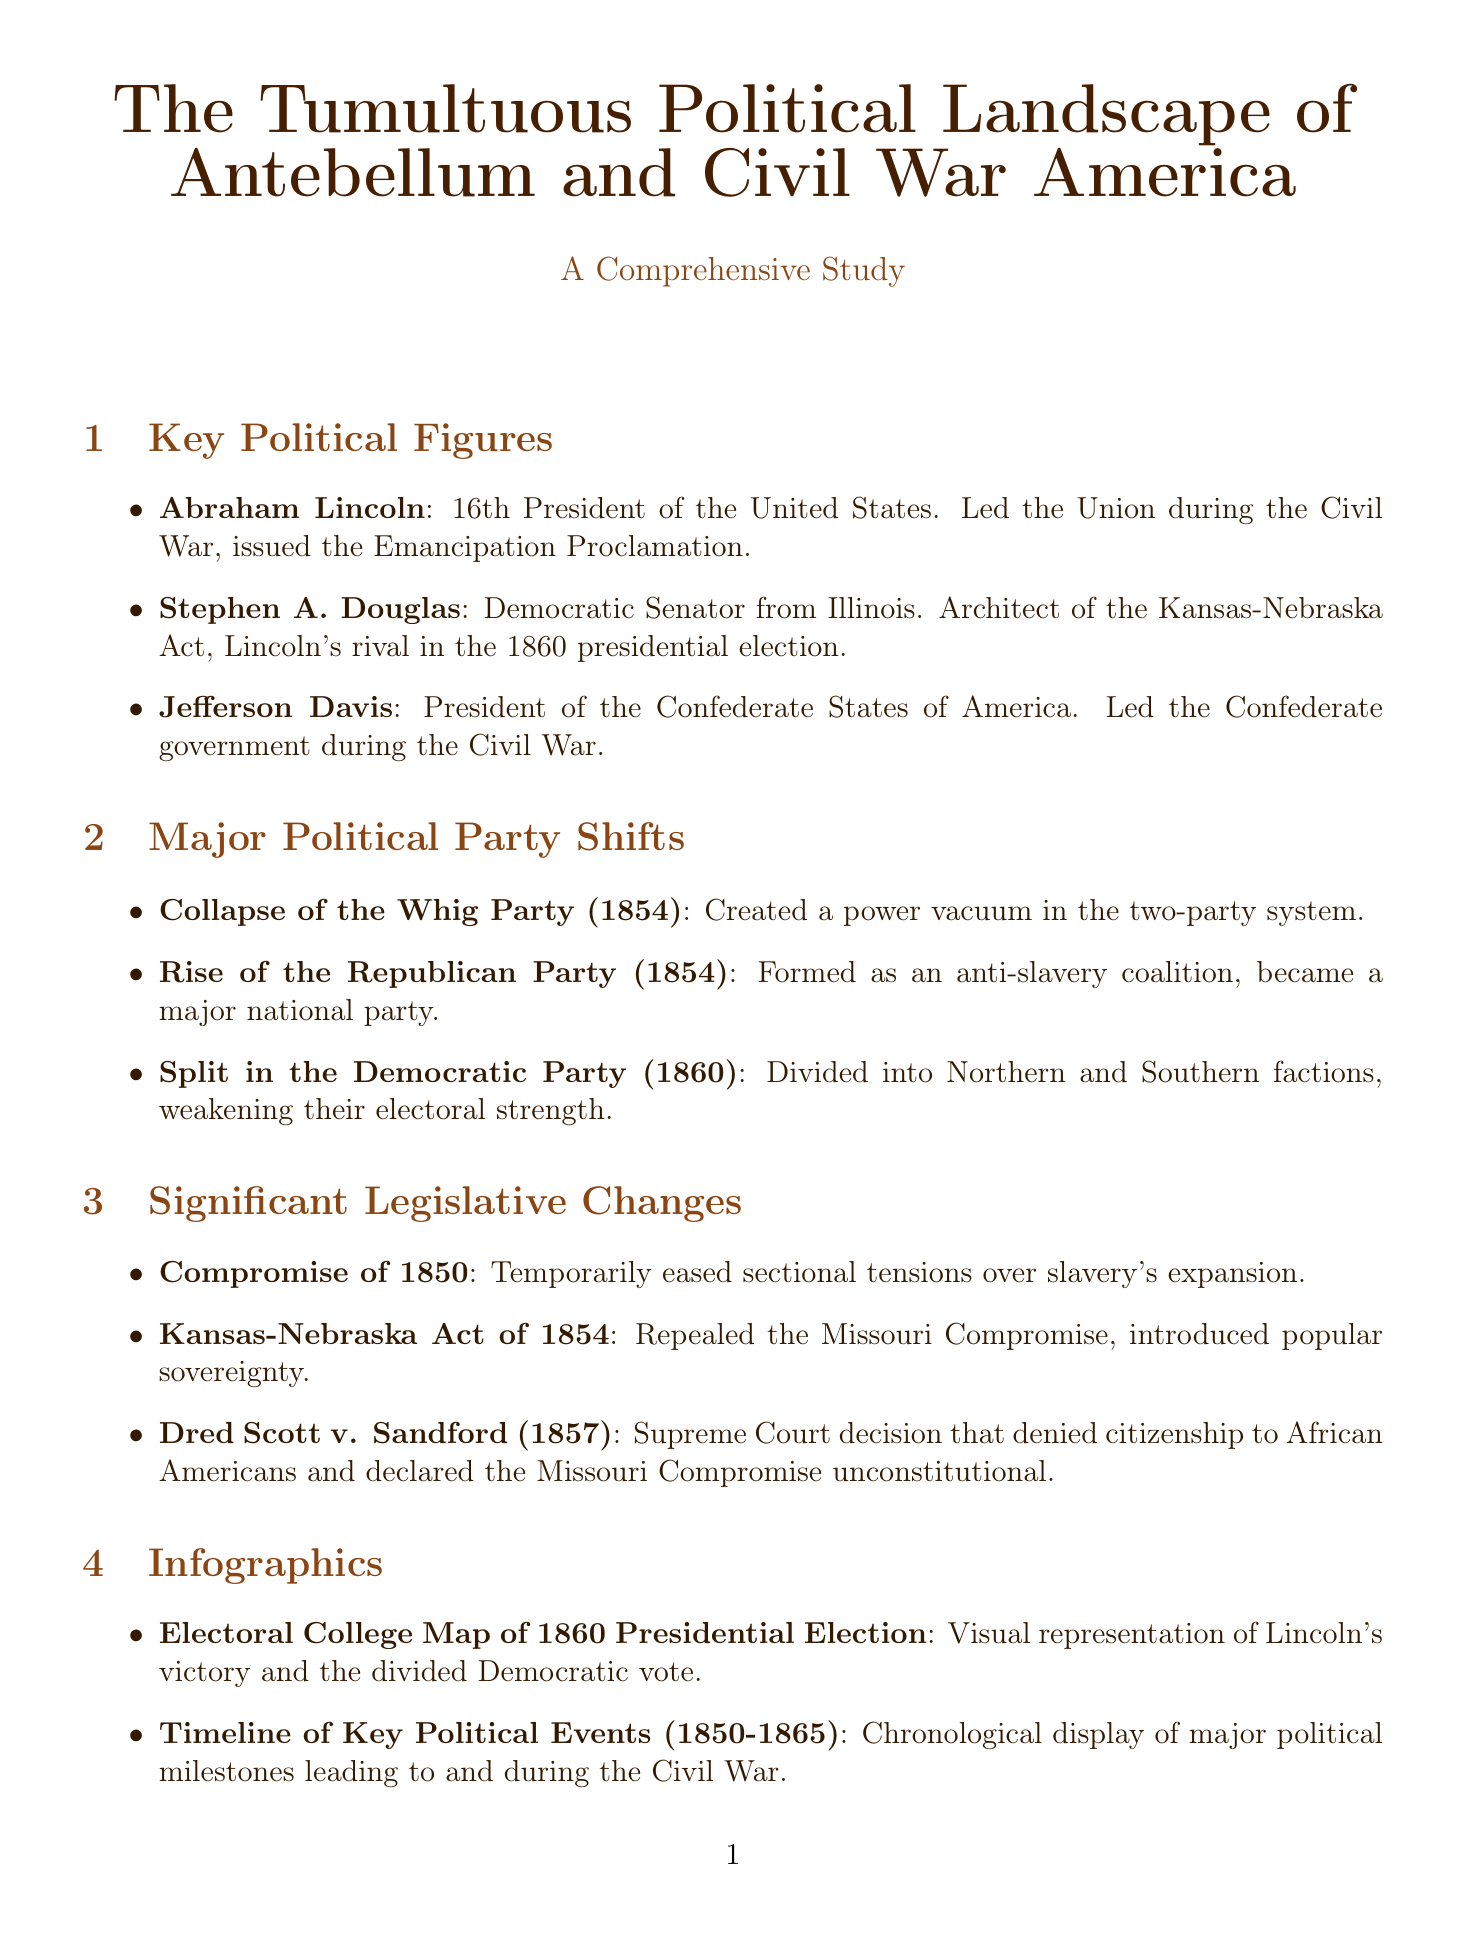What year did the Whig Party collapse? The document states that the Whig Party collapsed in the year 1854.
Answer: 1854 Who issued the Emancipation Proclamation? Abraham Lincoln, mentioned in the Key Political Figures section, is noted for issuing the Emancipation Proclamation.
Answer: Abraham Lincoln What was the main impact of the Kansas-Nebraska Act of 1854? The act is documented as repealing the Missouri Compromise and introducing popular sovereignty.
Answer: Introduced popular sovereignty Which political cartoon depicts Lincoln as a rail-splitter? The political cartoon titled "The Rail Candidate" by Louis Maurer illustrates Lincoln's image as a rail-splitter.
Answer: The Rail Candidate What are the key issues in the Deep South region? The document outlines the Deep South's key issues as preservation of slavery, state sovereignty, and agrarian economy.
Answer: Preservation of slavery, state sovereignty, agrarian economy What was the significance of the Dred Scott v. Sandford decision? The document explains that the decision denied citizenship to African Americans and declared the Missouri Compromise unconstitutional.
Answer: Denied citizenship to African Americans What political trend is associated with New England? According to the analysis, New England is recognized as a stronghold of abolitionism and Republican support.
Answer: Abolitionism and Republican support What shaped the political landscape of the 1850s and 1860s? The conclusion summarizes that intense sectional conflict, party realignment, and legislative battles shaped the political landscape.
Answer: Intense sectional conflict, party realignment, legislative battles 